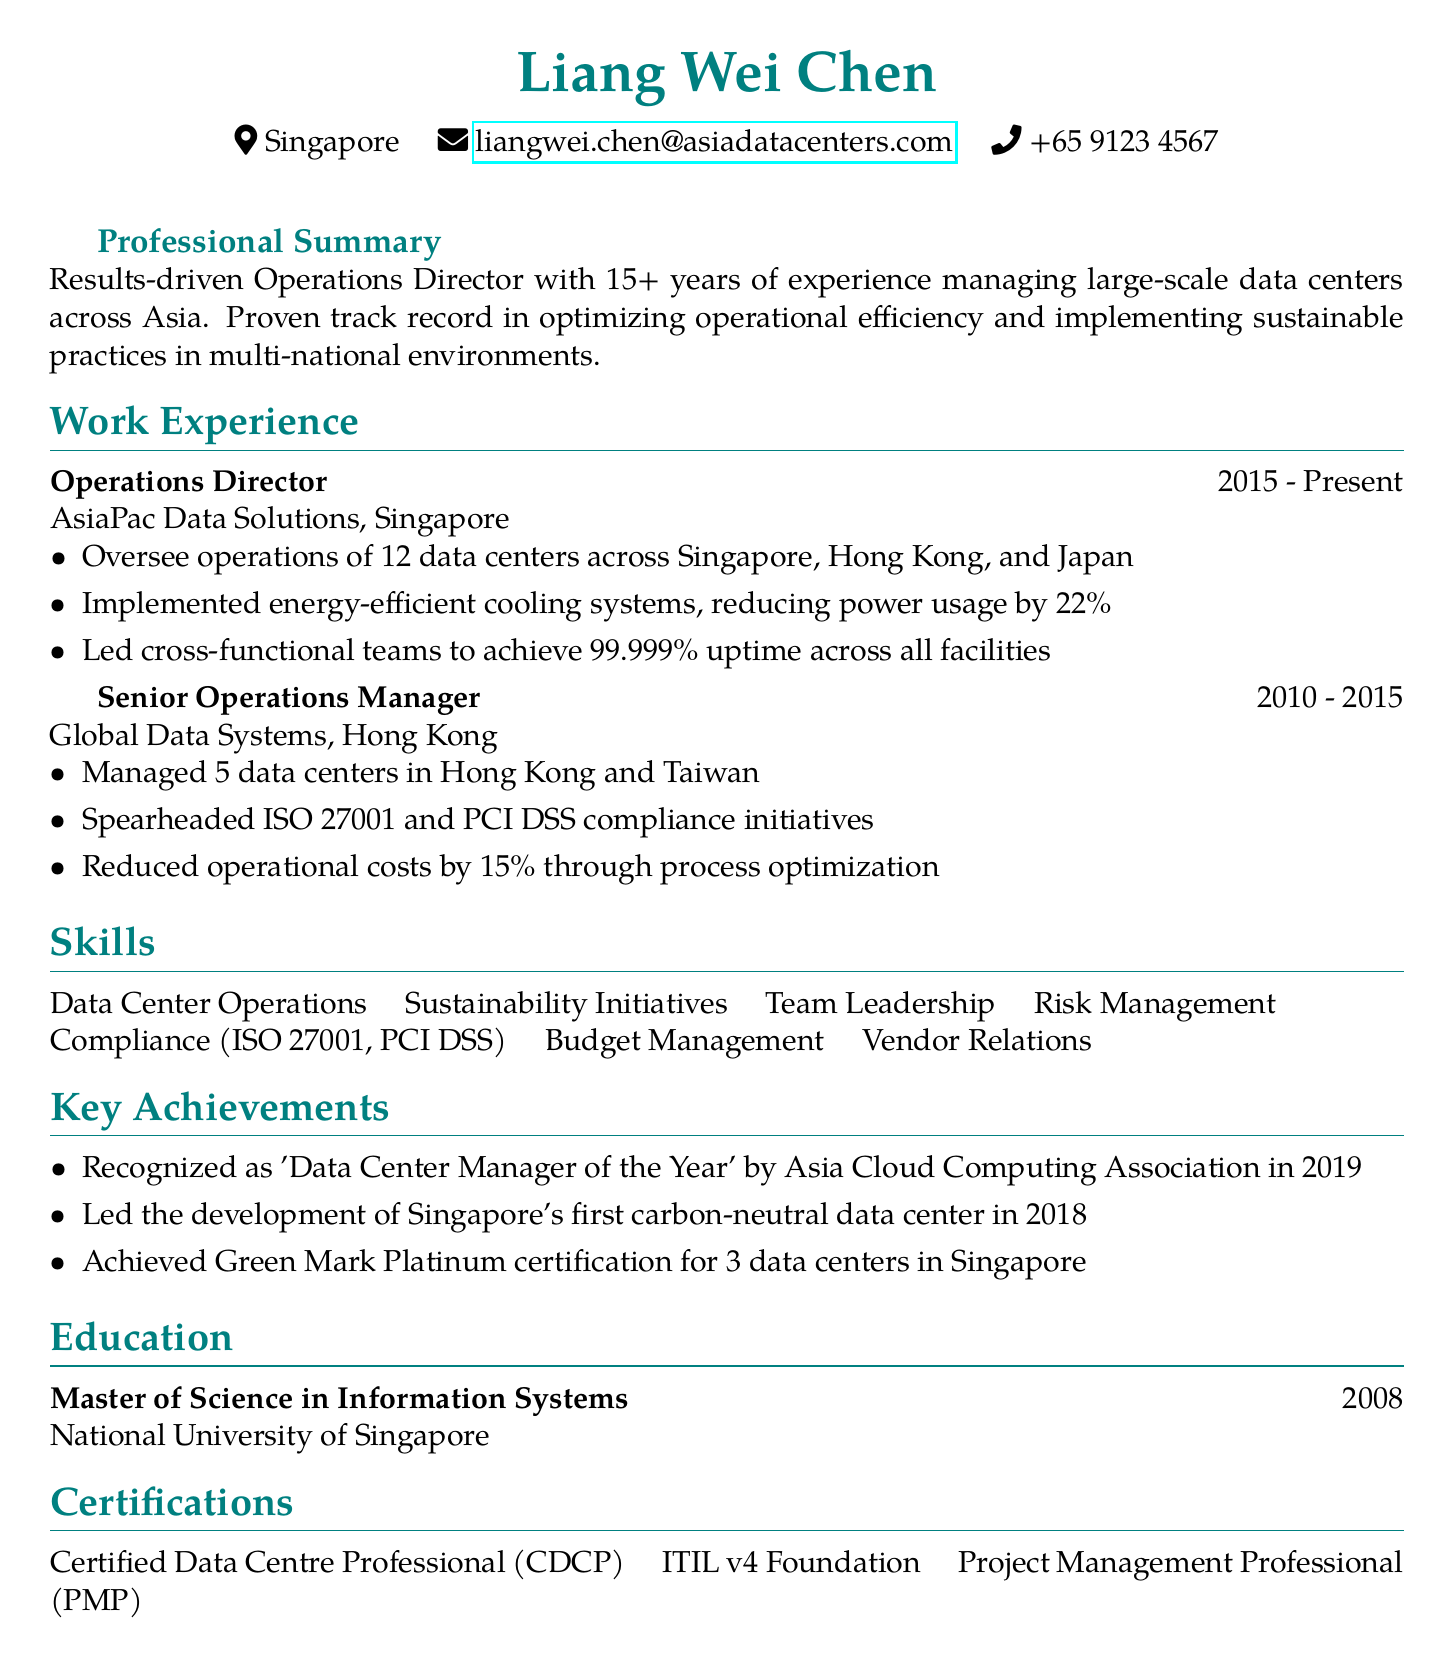what is the name of the Operations Director? The name listed in the document is the person’s full name, Liang Wei Chen.
Answer: Liang Wei Chen when did Liang Wei Chen start working at AsiaPac Data Solutions? The work experience section contains a start date for his position at AsiaPac Data Solutions, which is 2015.
Answer: 2015 how many data centers does Liang Wei Chen oversee at AsiaPac Data Solutions? The responsibilities under his current position specify that he oversees operations of 12 data centers.
Answer: 12 which certification indicates expertise in managing data centers? The certifications section lists a specific certification denoting expertise, which is Certified Data Centre Professional.
Answer: Certified Data Centre Professional (CDCP) what is the duration of Liang Wei Chen's experience in the data center industry? The professional summary states that he has 15+ years of experience.
Answer: 15+ years which achievement was recognized by the Asia Cloud Computing Association? One of the achievements listed indicates he was recognized with a specific title in 2019.
Answer: 'Data Center Manager of the Year' how much did operational costs decrease under Liang Wei Chen's management at Global Data Systems? The document mentions a percentage decrease in operational costs attributed to his efforts, specifically 15%.
Answer: 15% what degree did Liang Wei Chen earn, and in what year? The education section provides his degree and year of graduation.
Answer: Master of Science in Information Systems, 2008 